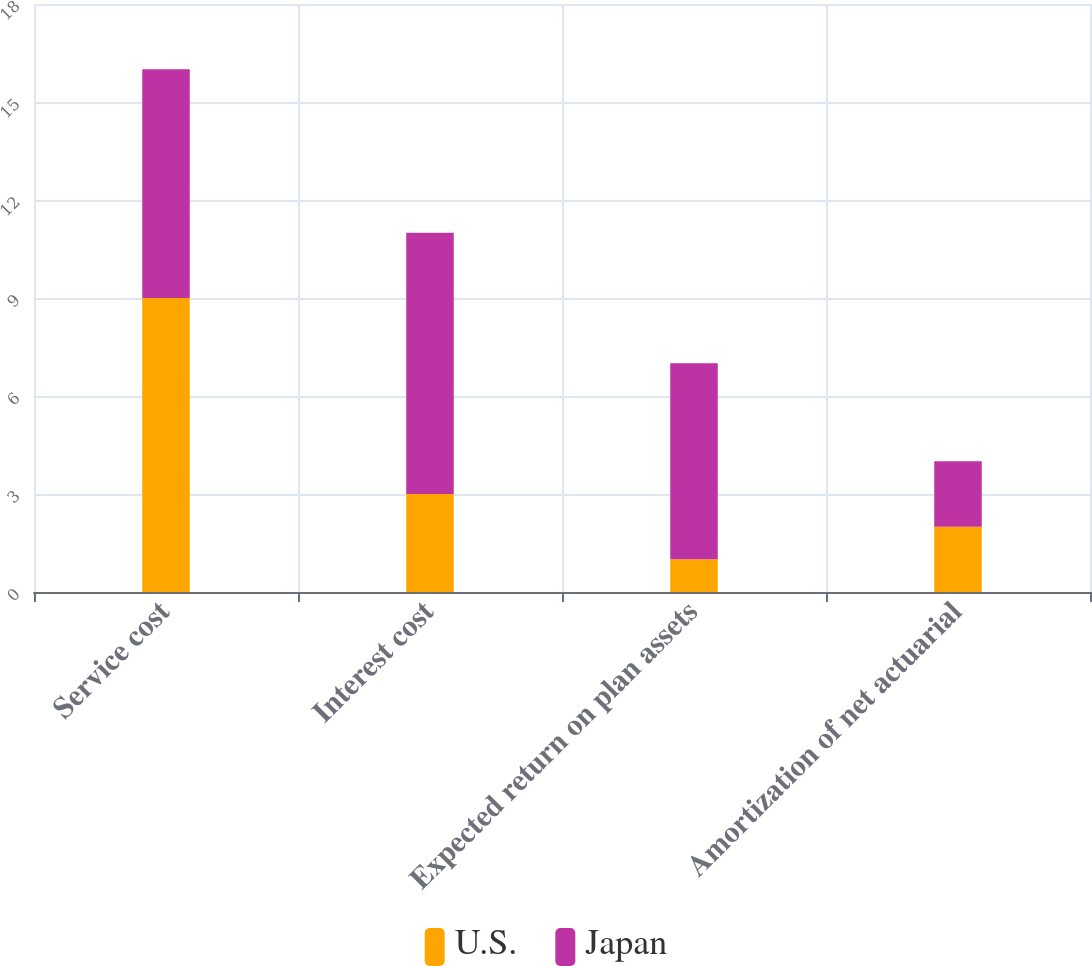Convert chart to OTSL. <chart><loc_0><loc_0><loc_500><loc_500><stacked_bar_chart><ecel><fcel>Service cost<fcel>Interest cost<fcel>Expected return on plan assets<fcel>Amortization of net actuarial<nl><fcel>U.S.<fcel>9<fcel>3<fcel>1<fcel>2<nl><fcel>Japan<fcel>7<fcel>8<fcel>6<fcel>2<nl></chart> 